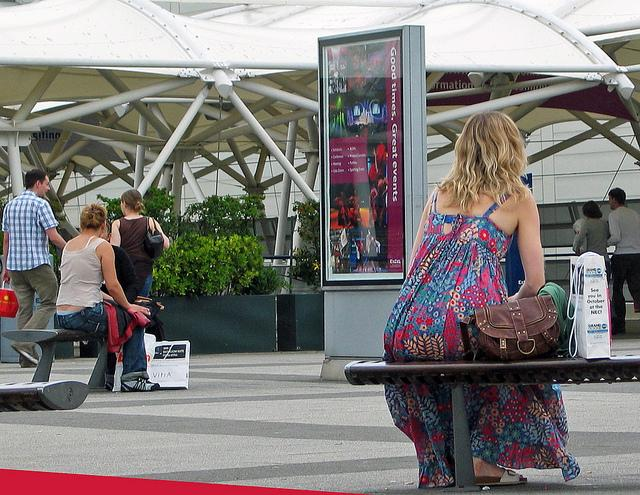What color is the leather of the woman's purse who is sitting on the bench to the right? brown 